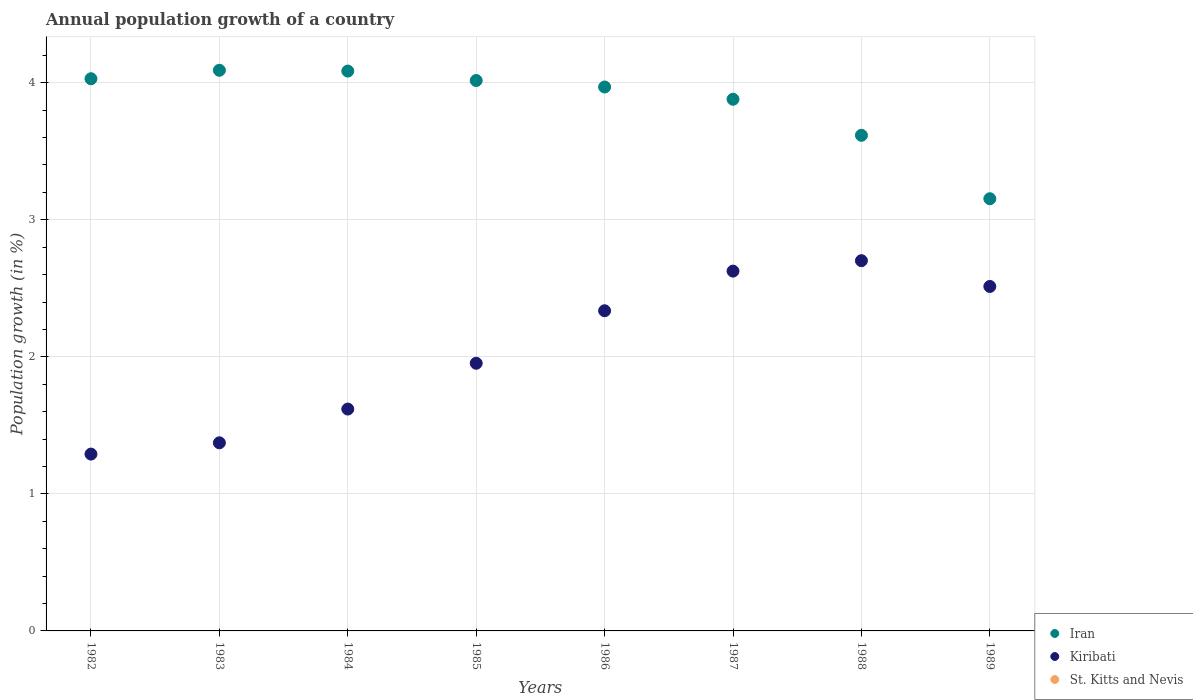Across all years, what is the maximum annual population growth in Iran?
Your response must be concise. 4.09. Across all years, what is the minimum annual population growth in St. Kitts and Nevis?
Offer a very short reply. 0. In which year was the annual population growth in Kiribati maximum?
Your response must be concise. 1988. What is the total annual population growth in Kiribati in the graph?
Your response must be concise. 16.41. What is the difference between the annual population growth in Iran in 1983 and that in 1986?
Give a very brief answer. 0.12. What is the difference between the annual population growth in Iran in 1982 and the annual population growth in St. Kitts and Nevis in 1987?
Your answer should be compact. 4.03. What is the average annual population growth in Kiribati per year?
Provide a short and direct response. 2.05. In the year 1985, what is the difference between the annual population growth in Kiribati and annual population growth in Iran?
Keep it short and to the point. -2.06. In how many years, is the annual population growth in Iran greater than 2.6 %?
Make the answer very short. 8. What is the ratio of the annual population growth in Iran in 1985 to that in 1986?
Make the answer very short. 1.01. What is the difference between the highest and the second highest annual population growth in Iran?
Provide a short and direct response. 0.01. What is the difference between the highest and the lowest annual population growth in Kiribati?
Keep it short and to the point. 1.41. In how many years, is the annual population growth in Iran greater than the average annual population growth in Iran taken over all years?
Make the answer very short. 6. Is the sum of the annual population growth in Kiribati in 1984 and 1989 greater than the maximum annual population growth in St. Kitts and Nevis across all years?
Keep it short and to the point. Yes. Is the annual population growth in St. Kitts and Nevis strictly greater than the annual population growth in Kiribati over the years?
Offer a terse response. No. Is the annual population growth in Iran strictly less than the annual population growth in Kiribati over the years?
Your answer should be compact. No. How many years are there in the graph?
Offer a terse response. 8. What is the difference between two consecutive major ticks on the Y-axis?
Your answer should be compact. 1. Does the graph contain any zero values?
Your answer should be very brief. Yes. Where does the legend appear in the graph?
Offer a terse response. Bottom right. How many legend labels are there?
Give a very brief answer. 3. How are the legend labels stacked?
Your response must be concise. Vertical. What is the title of the graph?
Offer a terse response. Annual population growth of a country. Does "Sub-Saharan Africa (developing only)" appear as one of the legend labels in the graph?
Your answer should be very brief. No. What is the label or title of the Y-axis?
Your answer should be compact. Population growth (in %). What is the Population growth (in %) of Iran in 1982?
Your answer should be very brief. 4.03. What is the Population growth (in %) in Kiribati in 1982?
Make the answer very short. 1.29. What is the Population growth (in %) in St. Kitts and Nevis in 1982?
Provide a succinct answer. 0. What is the Population growth (in %) of Iran in 1983?
Your response must be concise. 4.09. What is the Population growth (in %) of Kiribati in 1983?
Make the answer very short. 1.37. What is the Population growth (in %) of Iran in 1984?
Provide a short and direct response. 4.09. What is the Population growth (in %) in Kiribati in 1984?
Keep it short and to the point. 1.62. What is the Population growth (in %) of Iran in 1985?
Your answer should be very brief. 4.02. What is the Population growth (in %) of Kiribati in 1985?
Provide a short and direct response. 1.95. What is the Population growth (in %) of St. Kitts and Nevis in 1985?
Your answer should be compact. 0. What is the Population growth (in %) in Iran in 1986?
Give a very brief answer. 3.97. What is the Population growth (in %) of Kiribati in 1986?
Your answer should be compact. 2.34. What is the Population growth (in %) of Iran in 1987?
Keep it short and to the point. 3.88. What is the Population growth (in %) in Kiribati in 1987?
Ensure brevity in your answer.  2.63. What is the Population growth (in %) of Iran in 1988?
Offer a very short reply. 3.62. What is the Population growth (in %) of Kiribati in 1988?
Your answer should be very brief. 2.7. What is the Population growth (in %) in St. Kitts and Nevis in 1988?
Your response must be concise. 0. What is the Population growth (in %) of Iran in 1989?
Offer a very short reply. 3.15. What is the Population growth (in %) in Kiribati in 1989?
Provide a succinct answer. 2.51. Across all years, what is the maximum Population growth (in %) in Iran?
Make the answer very short. 4.09. Across all years, what is the maximum Population growth (in %) of Kiribati?
Your answer should be compact. 2.7. Across all years, what is the minimum Population growth (in %) in Iran?
Provide a succinct answer. 3.15. Across all years, what is the minimum Population growth (in %) in Kiribati?
Keep it short and to the point. 1.29. What is the total Population growth (in %) in Iran in the graph?
Offer a very short reply. 30.84. What is the total Population growth (in %) of Kiribati in the graph?
Provide a succinct answer. 16.41. What is the total Population growth (in %) in St. Kitts and Nevis in the graph?
Keep it short and to the point. 0. What is the difference between the Population growth (in %) in Iran in 1982 and that in 1983?
Your response must be concise. -0.06. What is the difference between the Population growth (in %) in Kiribati in 1982 and that in 1983?
Make the answer very short. -0.08. What is the difference between the Population growth (in %) of Iran in 1982 and that in 1984?
Make the answer very short. -0.06. What is the difference between the Population growth (in %) of Kiribati in 1982 and that in 1984?
Your answer should be compact. -0.33. What is the difference between the Population growth (in %) of Iran in 1982 and that in 1985?
Make the answer very short. 0.01. What is the difference between the Population growth (in %) in Kiribati in 1982 and that in 1985?
Ensure brevity in your answer.  -0.66. What is the difference between the Population growth (in %) in Iran in 1982 and that in 1986?
Provide a short and direct response. 0.06. What is the difference between the Population growth (in %) in Kiribati in 1982 and that in 1986?
Ensure brevity in your answer.  -1.05. What is the difference between the Population growth (in %) of Iran in 1982 and that in 1987?
Keep it short and to the point. 0.15. What is the difference between the Population growth (in %) in Kiribati in 1982 and that in 1987?
Ensure brevity in your answer.  -1.34. What is the difference between the Population growth (in %) in Iran in 1982 and that in 1988?
Your answer should be very brief. 0.41. What is the difference between the Population growth (in %) of Kiribati in 1982 and that in 1988?
Give a very brief answer. -1.41. What is the difference between the Population growth (in %) in Iran in 1982 and that in 1989?
Give a very brief answer. 0.88. What is the difference between the Population growth (in %) of Kiribati in 1982 and that in 1989?
Offer a terse response. -1.22. What is the difference between the Population growth (in %) in Iran in 1983 and that in 1984?
Keep it short and to the point. 0.01. What is the difference between the Population growth (in %) in Kiribati in 1983 and that in 1984?
Provide a succinct answer. -0.25. What is the difference between the Population growth (in %) in Iran in 1983 and that in 1985?
Keep it short and to the point. 0.07. What is the difference between the Population growth (in %) of Kiribati in 1983 and that in 1985?
Your answer should be compact. -0.58. What is the difference between the Population growth (in %) of Iran in 1983 and that in 1986?
Offer a very short reply. 0.12. What is the difference between the Population growth (in %) in Kiribati in 1983 and that in 1986?
Ensure brevity in your answer.  -0.96. What is the difference between the Population growth (in %) of Iran in 1983 and that in 1987?
Ensure brevity in your answer.  0.21. What is the difference between the Population growth (in %) of Kiribati in 1983 and that in 1987?
Give a very brief answer. -1.25. What is the difference between the Population growth (in %) of Iran in 1983 and that in 1988?
Ensure brevity in your answer.  0.47. What is the difference between the Population growth (in %) of Kiribati in 1983 and that in 1988?
Your response must be concise. -1.33. What is the difference between the Population growth (in %) of Iran in 1983 and that in 1989?
Your response must be concise. 0.94. What is the difference between the Population growth (in %) in Kiribati in 1983 and that in 1989?
Offer a very short reply. -1.14. What is the difference between the Population growth (in %) in Iran in 1984 and that in 1985?
Provide a succinct answer. 0.07. What is the difference between the Population growth (in %) in Kiribati in 1984 and that in 1985?
Give a very brief answer. -0.33. What is the difference between the Population growth (in %) in Iran in 1984 and that in 1986?
Your answer should be very brief. 0.12. What is the difference between the Population growth (in %) of Kiribati in 1984 and that in 1986?
Make the answer very short. -0.72. What is the difference between the Population growth (in %) of Iran in 1984 and that in 1987?
Offer a terse response. 0.21. What is the difference between the Population growth (in %) of Kiribati in 1984 and that in 1987?
Offer a terse response. -1.01. What is the difference between the Population growth (in %) of Iran in 1984 and that in 1988?
Ensure brevity in your answer.  0.47. What is the difference between the Population growth (in %) in Kiribati in 1984 and that in 1988?
Your answer should be compact. -1.08. What is the difference between the Population growth (in %) of Iran in 1984 and that in 1989?
Your answer should be compact. 0.93. What is the difference between the Population growth (in %) of Kiribati in 1984 and that in 1989?
Your response must be concise. -0.89. What is the difference between the Population growth (in %) of Iran in 1985 and that in 1986?
Your answer should be compact. 0.05. What is the difference between the Population growth (in %) in Kiribati in 1985 and that in 1986?
Offer a terse response. -0.38. What is the difference between the Population growth (in %) in Iran in 1985 and that in 1987?
Ensure brevity in your answer.  0.14. What is the difference between the Population growth (in %) in Kiribati in 1985 and that in 1987?
Offer a terse response. -0.67. What is the difference between the Population growth (in %) of Iran in 1985 and that in 1988?
Your answer should be very brief. 0.4. What is the difference between the Population growth (in %) in Kiribati in 1985 and that in 1988?
Offer a very short reply. -0.75. What is the difference between the Population growth (in %) in Iran in 1985 and that in 1989?
Your answer should be very brief. 0.86. What is the difference between the Population growth (in %) of Kiribati in 1985 and that in 1989?
Provide a succinct answer. -0.56. What is the difference between the Population growth (in %) in Iran in 1986 and that in 1987?
Your answer should be very brief. 0.09. What is the difference between the Population growth (in %) of Kiribati in 1986 and that in 1987?
Give a very brief answer. -0.29. What is the difference between the Population growth (in %) of Iran in 1986 and that in 1988?
Your response must be concise. 0.35. What is the difference between the Population growth (in %) of Kiribati in 1986 and that in 1988?
Offer a terse response. -0.37. What is the difference between the Population growth (in %) in Iran in 1986 and that in 1989?
Ensure brevity in your answer.  0.82. What is the difference between the Population growth (in %) of Kiribati in 1986 and that in 1989?
Keep it short and to the point. -0.18. What is the difference between the Population growth (in %) in Iran in 1987 and that in 1988?
Make the answer very short. 0.26. What is the difference between the Population growth (in %) in Kiribati in 1987 and that in 1988?
Offer a very short reply. -0.08. What is the difference between the Population growth (in %) of Iran in 1987 and that in 1989?
Keep it short and to the point. 0.73. What is the difference between the Population growth (in %) of Kiribati in 1987 and that in 1989?
Make the answer very short. 0.11. What is the difference between the Population growth (in %) in Iran in 1988 and that in 1989?
Provide a short and direct response. 0.46. What is the difference between the Population growth (in %) in Kiribati in 1988 and that in 1989?
Offer a very short reply. 0.19. What is the difference between the Population growth (in %) of Iran in 1982 and the Population growth (in %) of Kiribati in 1983?
Your response must be concise. 2.66. What is the difference between the Population growth (in %) of Iran in 1982 and the Population growth (in %) of Kiribati in 1984?
Offer a very short reply. 2.41. What is the difference between the Population growth (in %) of Iran in 1982 and the Population growth (in %) of Kiribati in 1985?
Keep it short and to the point. 2.08. What is the difference between the Population growth (in %) of Iran in 1982 and the Population growth (in %) of Kiribati in 1986?
Your answer should be very brief. 1.69. What is the difference between the Population growth (in %) of Iran in 1982 and the Population growth (in %) of Kiribati in 1987?
Provide a short and direct response. 1.4. What is the difference between the Population growth (in %) of Iran in 1982 and the Population growth (in %) of Kiribati in 1988?
Provide a short and direct response. 1.33. What is the difference between the Population growth (in %) of Iran in 1982 and the Population growth (in %) of Kiribati in 1989?
Make the answer very short. 1.52. What is the difference between the Population growth (in %) in Iran in 1983 and the Population growth (in %) in Kiribati in 1984?
Offer a very short reply. 2.47. What is the difference between the Population growth (in %) in Iran in 1983 and the Population growth (in %) in Kiribati in 1985?
Provide a short and direct response. 2.14. What is the difference between the Population growth (in %) of Iran in 1983 and the Population growth (in %) of Kiribati in 1986?
Make the answer very short. 1.75. What is the difference between the Population growth (in %) in Iran in 1983 and the Population growth (in %) in Kiribati in 1987?
Your answer should be compact. 1.47. What is the difference between the Population growth (in %) of Iran in 1983 and the Population growth (in %) of Kiribati in 1988?
Your answer should be very brief. 1.39. What is the difference between the Population growth (in %) in Iran in 1983 and the Population growth (in %) in Kiribati in 1989?
Ensure brevity in your answer.  1.58. What is the difference between the Population growth (in %) of Iran in 1984 and the Population growth (in %) of Kiribati in 1985?
Give a very brief answer. 2.13. What is the difference between the Population growth (in %) in Iran in 1984 and the Population growth (in %) in Kiribati in 1986?
Your response must be concise. 1.75. What is the difference between the Population growth (in %) of Iran in 1984 and the Population growth (in %) of Kiribati in 1987?
Provide a short and direct response. 1.46. What is the difference between the Population growth (in %) of Iran in 1984 and the Population growth (in %) of Kiribati in 1988?
Offer a terse response. 1.38. What is the difference between the Population growth (in %) in Iran in 1984 and the Population growth (in %) in Kiribati in 1989?
Your response must be concise. 1.57. What is the difference between the Population growth (in %) in Iran in 1985 and the Population growth (in %) in Kiribati in 1986?
Your answer should be compact. 1.68. What is the difference between the Population growth (in %) in Iran in 1985 and the Population growth (in %) in Kiribati in 1987?
Your response must be concise. 1.39. What is the difference between the Population growth (in %) in Iran in 1985 and the Population growth (in %) in Kiribati in 1988?
Provide a short and direct response. 1.31. What is the difference between the Population growth (in %) in Iran in 1985 and the Population growth (in %) in Kiribati in 1989?
Provide a short and direct response. 1.5. What is the difference between the Population growth (in %) of Iran in 1986 and the Population growth (in %) of Kiribati in 1987?
Keep it short and to the point. 1.34. What is the difference between the Population growth (in %) of Iran in 1986 and the Population growth (in %) of Kiribati in 1988?
Make the answer very short. 1.27. What is the difference between the Population growth (in %) of Iran in 1986 and the Population growth (in %) of Kiribati in 1989?
Keep it short and to the point. 1.46. What is the difference between the Population growth (in %) in Iran in 1987 and the Population growth (in %) in Kiribati in 1988?
Provide a succinct answer. 1.18. What is the difference between the Population growth (in %) of Iran in 1987 and the Population growth (in %) of Kiribati in 1989?
Provide a short and direct response. 1.37. What is the difference between the Population growth (in %) of Iran in 1988 and the Population growth (in %) of Kiribati in 1989?
Keep it short and to the point. 1.1. What is the average Population growth (in %) in Iran per year?
Your answer should be compact. 3.86. What is the average Population growth (in %) of Kiribati per year?
Provide a succinct answer. 2.05. What is the average Population growth (in %) of St. Kitts and Nevis per year?
Give a very brief answer. 0. In the year 1982, what is the difference between the Population growth (in %) in Iran and Population growth (in %) in Kiribati?
Your response must be concise. 2.74. In the year 1983, what is the difference between the Population growth (in %) in Iran and Population growth (in %) in Kiribati?
Offer a terse response. 2.72. In the year 1984, what is the difference between the Population growth (in %) in Iran and Population growth (in %) in Kiribati?
Make the answer very short. 2.47. In the year 1985, what is the difference between the Population growth (in %) in Iran and Population growth (in %) in Kiribati?
Offer a very short reply. 2.06. In the year 1986, what is the difference between the Population growth (in %) of Iran and Population growth (in %) of Kiribati?
Give a very brief answer. 1.63. In the year 1987, what is the difference between the Population growth (in %) in Iran and Population growth (in %) in Kiribati?
Your answer should be compact. 1.25. In the year 1988, what is the difference between the Population growth (in %) in Iran and Population growth (in %) in Kiribati?
Keep it short and to the point. 0.91. In the year 1989, what is the difference between the Population growth (in %) in Iran and Population growth (in %) in Kiribati?
Provide a succinct answer. 0.64. What is the ratio of the Population growth (in %) in Iran in 1982 to that in 1983?
Give a very brief answer. 0.98. What is the ratio of the Population growth (in %) of Kiribati in 1982 to that in 1983?
Offer a very short reply. 0.94. What is the ratio of the Population growth (in %) in Iran in 1982 to that in 1984?
Provide a succinct answer. 0.99. What is the ratio of the Population growth (in %) in Kiribati in 1982 to that in 1984?
Your answer should be compact. 0.8. What is the ratio of the Population growth (in %) of Iran in 1982 to that in 1985?
Provide a succinct answer. 1. What is the ratio of the Population growth (in %) of Kiribati in 1982 to that in 1985?
Provide a short and direct response. 0.66. What is the ratio of the Population growth (in %) of Iran in 1982 to that in 1986?
Provide a short and direct response. 1.02. What is the ratio of the Population growth (in %) in Kiribati in 1982 to that in 1986?
Your answer should be compact. 0.55. What is the ratio of the Population growth (in %) of Iran in 1982 to that in 1987?
Your response must be concise. 1.04. What is the ratio of the Population growth (in %) of Kiribati in 1982 to that in 1987?
Your answer should be very brief. 0.49. What is the ratio of the Population growth (in %) in Iran in 1982 to that in 1988?
Offer a terse response. 1.11. What is the ratio of the Population growth (in %) of Kiribati in 1982 to that in 1988?
Ensure brevity in your answer.  0.48. What is the ratio of the Population growth (in %) in Iran in 1982 to that in 1989?
Ensure brevity in your answer.  1.28. What is the ratio of the Population growth (in %) in Kiribati in 1982 to that in 1989?
Provide a succinct answer. 0.51. What is the ratio of the Population growth (in %) in Kiribati in 1983 to that in 1984?
Keep it short and to the point. 0.85. What is the ratio of the Population growth (in %) in Iran in 1983 to that in 1985?
Your answer should be very brief. 1.02. What is the ratio of the Population growth (in %) of Kiribati in 1983 to that in 1985?
Your answer should be very brief. 0.7. What is the ratio of the Population growth (in %) of Iran in 1983 to that in 1986?
Keep it short and to the point. 1.03. What is the ratio of the Population growth (in %) of Kiribati in 1983 to that in 1986?
Your answer should be compact. 0.59. What is the ratio of the Population growth (in %) of Iran in 1983 to that in 1987?
Offer a very short reply. 1.05. What is the ratio of the Population growth (in %) in Kiribati in 1983 to that in 1987?
Ensure brevity in your answer.  0.52. What is the ratio of the Population growth (in %) of Iran in 1983 to that in 1988?
Your response must be concise. 1.13. What is the ratio of the Population growth (in %) in Kiribati in 1983 to that in 1988?
Give a very brief answer. 0.51. What is the ratio of the Population growth (in %) in Iran in 1983 to that in 1989?
Offer a very short reply. 1.3. What is the ratio of the Population growth (in %) in Kiribati in 1983 to that in 1989?
Ensure brevity in your answer.  0.55. What is the ratio of the Population growth (in %) of Iran in 1984 to that in 1985?
Offer a terse response. 1.02. What is the ratio of the Population growth (in %) in Kiribati in 1984 to that in 1985?
Offer a terse response. 0.83. What is the ratio of the Population growth (in %) of Iran in 1984 to that in 1986?
Ensure brevity in your answer.  1.03. What is the ratio of the Population growth (in %) of Kiribati in 1984 to that in 1986?
Provide a short and direct response. 0.69. What is the ratio of the Population growth (in %) of Iran in 1984 to that in 1987?
Your answer should be very brief. 1.05. What is the ratio of the Population growth (in %) in Kiribati in 1984 to that in 1987?
Offer a very short reply. 0.62. What is the ratio of the Population growth (in %) in Iran in 1984 to that in 1988?
Your answer should be compact. 1.13. What is the ratio of the Population growth (in %) in Kiribati in 1984 to that in 1988?
Provide a succinct answer. 0.6. What is the ratio of the Population growth (in %) in Iran in 1984 to that in 1989?
Your answer should be very brief. 1.3. What is the ratio of the Population growth (in %) in Kiribati in 1984 to that in 1989?
Make the answer very short. 0.64. What is the ratio of the Population growth (in %) in Iran in 1985 to that in 1986?
Offer a terse response. 1.01. What is the ratio of the Population growth (in %) of Kiribati in 1985 to that in 1986?
Give a very brief answer. 0.84. What is the ratio of the Population growth (in %) of Iran in 1985 to that in 1987?
Make the answer very short. 1.04. What is the ratio of the Population growth (in %) in Kiribati in 1985 to that in 1987?
Provide a succinct answer. 0.74. What is the ratio of the Population growth (in %) of Iran in 1985 to that in 1988?
Your response must be concise. 1.11. What is the ratio of the Population growth (in %) in Kiribati in 1985 to that in 1988?
Your response must be concise. 0.72. What is the ratio of the Population growth (in %) of Iran in 1985 to that in 1989?
Provide a short and direct response. 1.27. What is the ratio of the Population growth (in %) in Kiribati in 1985 to that in 1989?
Keep it short and to the point. 0.78. What is the ratio of the Population growth (in %) of Iran in 1986 to that in 1987?
Offer a very short reply. 1.02. What is the ratio of the Population growth (in %) of Kiribati in 1986 to that in 1987?
Keep it short and to the point. 0.89. What is the ratio of the Population growth (in %) in Iran in 1986 to that in 1988?
Keep it short and to the point. 1.1. What is the ratio of the Population growth (in %) of Kiribati in 1986 to that in 1988?
Keep it short and to the point. 0.86. What is the ratio of the Population growth (in %) of Iran in 1986 to that in 1989?
Offer a very short reply. 1.26. What is the ratio of the Population growth (in %) in Kiribati in 1986 to that in 1989?
Ensure brevity in your answer.  0.93. What is the ratio of the Population growth (in %) in Iran in 1987 to that in 1988?
Give a very brief answer. 1.07. What is the ratio of the Population growth (in %) in Kiribati in 1987 to that in 1988?
Make the answer very short. 0.97. What is the ratio of the Population growth (in %) of Iran in 1987 to that in 1989?
Offer a very short reply. 1.23. What is the ratio of the Population growth (in %) in Kiribati in 1987 to that in 1989?
Provide a short and direct response. 1.04. What is the ratio of the Population growth (in %) of Iran in 1988 to that in 1989?
Keep it short and to the point. 1.15. What is the ratio of the Population growth (in %) in Kiribati in 1988 to that in 1989?
Provide a short and direct response. 1.07. What is the difference between the highest and the second highest Population growth (in %) in Iran?
Offer a terse response. 0.01. What is the difference between the highest and the second highest Population growth (in %) of Kiribati?
Your answer should be very brief. 0.08. What is the difference between the highest and the lowest Population growth (in %) in Iran?
Offer a very short reply. 0.94. What is the difference between the highest and the lowest Population growth (in %) in Kiribati?
Provide a short and direct response. 1.41. 